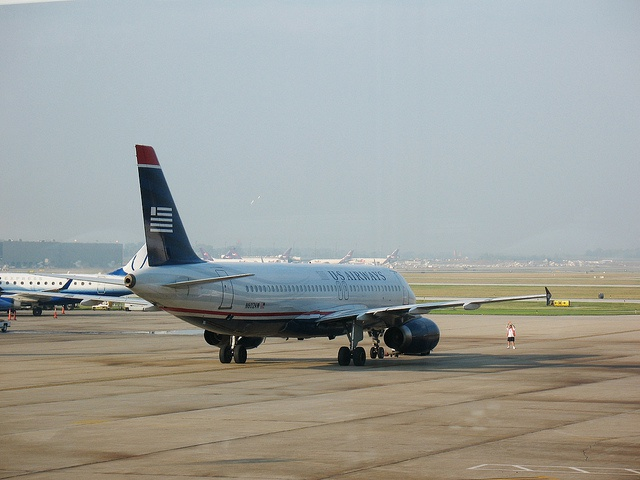Describe the objects in this image and their specific colors. I can see airplane in lightgray, black, gray, and darkgray tones, airplane in lightgray, darkgray, black, and gray tones, airplane in lightgray and darkgray tones, airplane in lightgray and darkgray tones, and people in lightgray, tan, black, and darkgray tones in this image. 